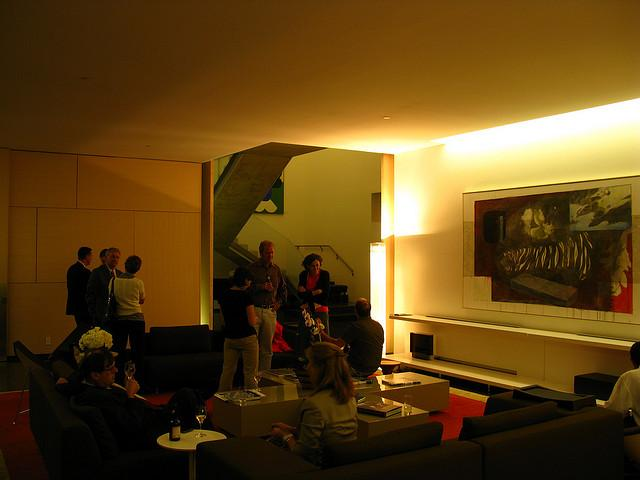What is the design of the staircase called? Please explain your reasoning. l-shaped staircase. It is called an ishape case. 